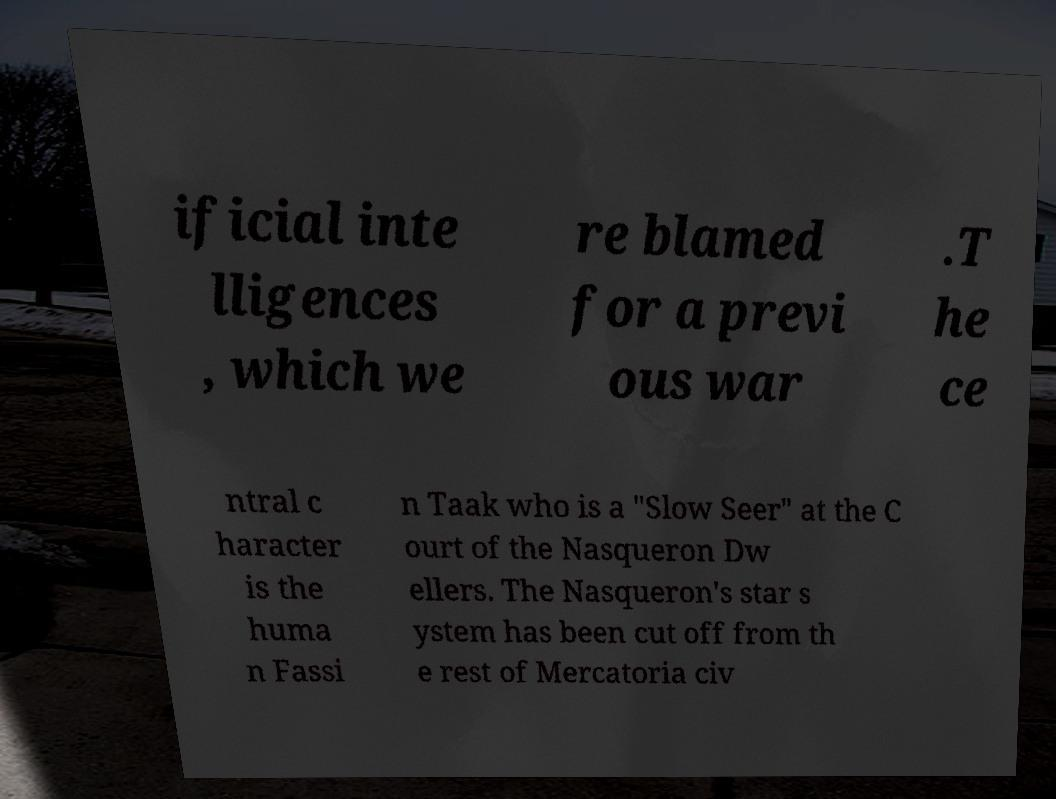Please read and relay the text visible in this image. What does it say? ificial inte lligences , which we re blamed for a previ ous war .T he ce ntral c haracter is the huma n Fassi n Taak who is a "Slow Seer" at the C ourt of the Nasqueron Dw ellers. The Nasqueron's star s ystem has been cut off from th e rest of Mercatoria civ 